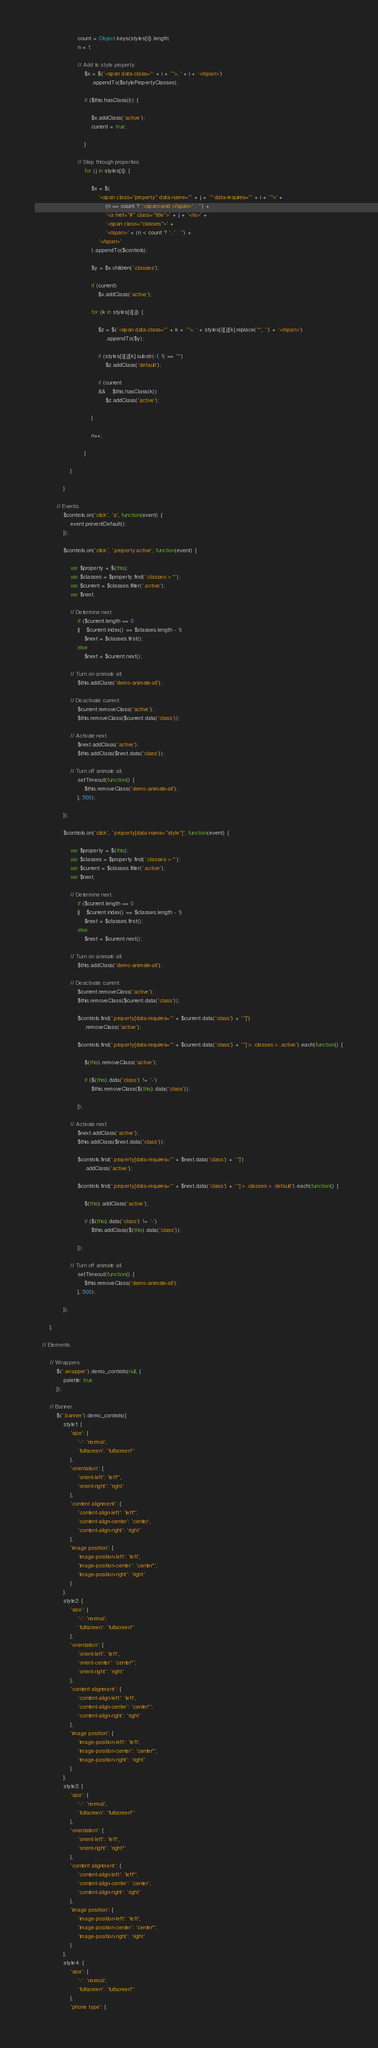<code> <loc_0><loc_0><loc_500><loc_500><_JavaScript_>						count = Object.keys(styles[i]).length;
						n = 1;

						// Add to style property.
							$x = $('<span data-class="' + i + '">, ' + i + '</span>')
								.appendTo($stylePropertyClasses);

							if ($this.hasClass(i)) {

								$x.addClass('active');
								current = true;

							}

						// Step through properties.
							for (j in styles[i]) {

								$x = $(
									'<span class="property" data-name="' + j + '" data-requires="' + i + '">' +
										(n == count ? '<span>and </span>' : '') +
										'<a href="#" class="title">' + j + '</a>' +
										'<span class="classes">' +
										'</span>' + (n < count ? ', ' : '') +
									'</span>'
								).appendTo($controls);

								$y = $x.children('.classes');

								if (current)
									$x.addClass('active');

								for (k in styles[i][j]) {

									$z = $('<span data-class="' + k + '">, ' + styles[i][j][k].replace('*', '') + '</span>')
										.appendTo($y);

									if (styles[i][j][k].substr(-1, 1) == '*')
										$z.addClass('default');

									if (current
									&&	$this.hasClass(k))
										$z.addClass('active');

								}

								n++;

							}

					}

				}

			// Events.
				$controls.on('click', 'a', function(event) {
					event.preventDefault();
				});

				$controls.on('click', '.property.active', function(event) {

					var $property = $(this);
					var $classes = $property.find('.classes > *');
					var $current = $classes.filter('.active');
					var $next;

					// Determine next.
						if ($current.length == 0
						||	$current.index() == $classes.length - 1)
							$next = $classes.first();
						else
							$next = $current.next();

					// Turn on animate all.
						$this.addClass('demo-animate-all');

					// Deactivate current.
						$current.removeClass('active');
						$this.removeClass($current.data('class'));

					// Activate next.
						$next.addClass('active');
						$this.addClass($next.data('class'));

					// Turn off animate all.
						setTimeout(function() {
							$this.removeClass('demo-animate-all');
						}, 500);

				});

				$controls.on('click', '.property[data-name="style"]', function(event) {

					var $property = $(this);
					var $classes = $property.find('.classes > *');
					var $current = $classes.filter('.active');
					var $next;

					// Determine next.
						if ($current.length == 0
						||	$current.index() == $classes.length - 1)
							$next = $classes.first();
						else
							$next = $current.next();

					// Turn on animate all.
						$this.addClass('demo-animate-all');

					// Deactivate current.
						$current.removeClass('active');
						$this.removeClass($current.data('class'));

						$controls.find('.property[data-requires="' + $current.data('class') + '"]')
							.removeClass('active');

						$controls.find('.property[data-requires="' + $current.data('class') + '"] > .classes > .active').each(function() {

							$(this).removeClass('active');

							if ($(this).data('class') != '-')
								$this.removeClass($(this).data('class'));

						});

					// Activate next.
						$next.addClass('active');
						$this.addClass($next.data('class'));

						$controls.find('.property[data-requires="' + $next.data('class') + '"]')
							.addClass('active');

						$controls.find('.property[data-requires="' + $next.data('class') + '"] > .classes > .default').each(function() {

							$(this).addClass('active');

							if ($(this).data('class') != '-')
								$this.addClass($(this).data('class'));

						});

					// Turn off animate all.
						setTimeout(function() {
							$this.removeClass('demo-animate-all');
						}, 500);

				});

		};

	// Elements.

		// Wrappers.
			$('.wrapper').demo_controls(null, {
				palette: true
			});

		// Banner.
			$('.banner').demo_controls({
				style1: {
					'size': {
						'-': 'normal',
						'fullscreen': 'fullscreen*'
					},
					'orientation': {
						'orient-left': 'left*',
						'orient-right': 'right'
					},
					'content alignment': {
						'content-align-left': 'left*',
						'content-align-center': 'center',
						'content-align-right': 'right'
					},
					'image position': {
						'image-position-left': 'left',
						'image-position-center': 'center*',
						'image-position-right': 'right'
					}
				},
				style2: {
					'size': {
						'-': 'normal',
						'fullscreen': 'fullscreen*'
					},
					'orientation': {
						'orient-left': 'left',
						'orient-center': 'center*',
						'orient-right': 'right'
					},
					'content alignment': {
						'content-align-left': 'left',
						'content-align-center': 'center*',
						'content-align-right': 'right'
					},
					'image position': {
						'image-position-left': 'left',
						'image-position-center': 'center*',
						'image-position-right': 'right'
					}
				},
				style3: {
					'size': {
						'-': 'normal',
						'fullscreen': 'fullscreen*'
					},
					'orientation': {
						'orient-left': 'left',
						'orient-right': 'right*'
					},
					'content alignment': {
						'content-align-left': 'left*',
						'content-align-center': 'center',
						'content-align-right': 'right'
					},
					'image position': {
						'image-position-left': 'left',
						'image-position-center': 'center*',
						'image-position-right': 'right'
					}
				},
				style4: {
					'size': {
						'-': 'normal',
						'fullscreen': 'fullscreen*'
					},
					'phone type': {</code> 